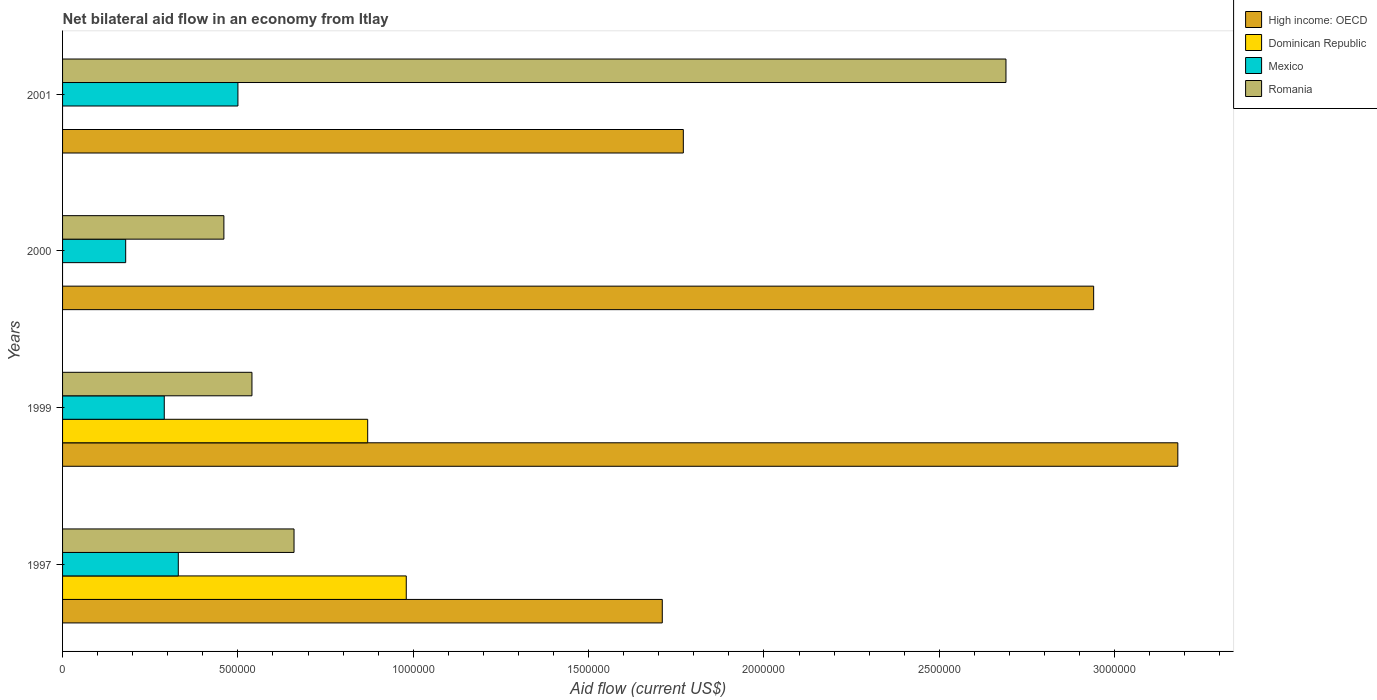How many different coloured bars are there?
Make the answer very short. 4. How many bars are there on the 2nd tick from the top?
Offer a very short reply. 3. How many bars are there on the 4th tick from the bottom?
Your response must be concise. 3. In how many cases, is the number of bars for a given year not equal to the number of legend labels?
Make the answer very short. 2. What is the net bilateral aid flow in High income: OECD in 1999?
Ensure brevity in your answer.  3.18e+06. Across all years, what is the maximum net bilateral aid flow in Dominican Republic?
Provide a succinct answer. 9.80e+05. Across all years, what is the minimum net bilateral aid flow in High income: OECD?
Give a very brief answer. 1.71e+06. What is the total net bilateral aid flow in Mexico in the graph?
Ensure brevity in your answer.  1.30e+06. What is the average net bilateral aid flow in Mexico per year?
Ensure brevity in your answer.  3.25e+05. In the year 2001, what is the difference between the net bilateral aid flow in High income: OECD and net bilateral aid flow in Romania?
Provide a succinct answer. -9.20e+05. In how many years, is the net bilateral aid flow in Mexico greater than 700000 US$?
Your answer should be compact. 0. What is the ratio of the net bilateral aid flow in Mexico in 1997 to that in 2001?
Your answer should be very brief. 0.66. Is the net bilateral aid flow in Romania in 1997 less than that in 2001?
Offer a terse response. Yes. What is the difference between the highest and the second highest net bilateral aid flow in Mexico?
Your response must be concise. 1.70e+05. What is the difference between the highest and the lowest net bilateral aid flow in Romania?
Provide a succinct answer. 2.23e+06. In how many years, is the net bilateral aid flow in High income: OECD greater than the average net bilateral aid flow in High income: OECD taken over all years?
Keep it short and to the point. 2. How many years are there in the graph?
Provide a succinct answer. 4. Are the values on the major ticks of X-axis written in scientific E-notation?
Ensure brevity in your answer.  No. Does the graph contain any zero values?
Offer a very short reply. Yes. Does the graph contain grids?
Provide a succinct answer. No. Where does the legend appear in the graph?
Keep it short and to the point. Top right. How are the legend labels stacked?
Offer a terse response. Vertical. What is the title of the graph?
Provide a succinct answer. Net bilateral aid flow in an economy from Itlay. What is the label or title of the X-axis?
Offer a terse response. Aid flow (current US$). What is the label or title of the Y-axis?
Your answer should be compact. Years. What is the Aid flow (current US$) in High income: OECD in 1997?
Provide a succinct answer. 1.71e+06. What is the Aid flow (current US$) of Dominican Republic in 1997?
Provide a short and direct response. 9.80e+05. What is the Aid flow (current US$) in Romania in 1997?
Offer a terse response. 6.60e+05. What is the Aid flow (current US$) of High income: OECD in 1999?
Your answer should be very brief. 3.18e+06. What is the Aid flow (current US$) in Dominican Republic in 1999?
Your answer should be compact. 8.70e+05. What is the Aid flow (current US$) of Romania in 1999?
Your answer should be very brief. 5.40e+05. What is the Aid flow (current US$) of High income: OECD in 2000?
Provide a succinct answer. 2.94e+06. What is the Aid flow (current US$) in Dominican Republic in 2000?
Keep it short and to the point. 0. What is the Aid flow (current US$) of Mexico in 2000?
Give a very brief answer. 1.80e+05. What is the Aid flow (current US$) of Romania in 2000?
Your answer should be very brief. 4.60e+05. What is the Aid flow (current US$) in High income: OECD in 2001?
Your answer should be compact. 1.77e+06. What is the Aid flow (current US$) in Mexico in 2001?
Provide a succinct answer. 5.00e+05. What is the Aid flow (current US$) of Romania in 2001?
Ensure brevity in your answer.  2.69e+06. Across all years, what is the maximum Aid flow (current US$) in High income: OECD?
Your answer should be compact. 3.18e+06. Across all years, what is the maximum Aid flow (current US$) of Dominican Republic?
Keep it short and to the point. 9.80e+05. Across all years, what is the maximum Aid flow (current US$) of Mexico?
Your response must be concise. 5.00e+05. Across all years, what is the maximum Aid flow (current US$) in Romania?
Provide a succinct answer. 2.69e+06. Across all years, what is the minimum Aid flow (current US$) of High income: OECD?
Your answer should be compact. 1.71e+06. Across all years, what is the minimum Aid flow (current US$) in Dominican Republic?
Keep it short and to the point. 0. Across all years, what is the minimum Aid flow (current US$) in Mexico?
Offer a very short reply. 1.80e+05. What is the total Aid flow (current US$) of High income: OECD in the graph?
Make the answer very short. 9.60e+06. What is the total Aid flow (current US$) in Dominican Republic in the graph?
Offer a very short reply. 1.85e+06. What is the total Aid flow (current US$) of Mexico in the graph?
Offer a terse response. 1.30e+06. What is the total Aid flow (current US$) of Romania in the graph?
Keep it short and to the point. 4.35e+06. What is the difference between the Aid flow (current US$) of High income: OECD in 1997 and that in 1999?
Ensure brevity in your answer.  -1.47e+06. What is the difference between the Aid flow (current US$) of Romania in 1997 and that in 1999?
Keep it short and to the point. 1.20e+05. What is the difference between the Aid flow (current US$) in High income: OECD in 1997 and that in 2000?
Make the answer very short. -1.23e+06. What is the difference between the Aid flow (current US$) in Mexico in 1997 and that in 2000?
Offer a terse response. 1.50e+05. What is the difference between the Aid flow (current US$) of Romania in 1997 and that in 2001?
Keep it short and to the point. -2.03e+06. What is the difference between the Aid flow (current US$) of High income: OECD in 1999 and that in 2000?
Provide a succinct answer. 2.40e+05. What is the difference between the Aid flow (current US$) of Mexico in 1999 and that in 2000?
Your answer should be compact. 1.10e+05. What is the difference between the Aid flow (current US$) in High income: OECD in 1999 and that in 2001?
Provide a short and direct response. 1.41e+06. What is the difference between the Aid flow (current US$) of Romania in 1999 and that in 2001?
Your answer should be very brief. -2.15e+06. What is the difference between the Aid flow (current US$) of High income: OECD in 2000 and that in 2001?
Give a very brief answer. 1.17e+06. What is the difference between the Aid flow (current US$) in Mexico in 2000 and that in 2001?
Keep it short and to the point. -3.20e+05. What is the difference between the Aid flow (current US$) of Romania in 2000 and that in 2001?
Your answer should be compact. -2.23e+06. What is the difference between the Aid flow (current US$) of High income: OECD in 1997 and the Aid flow (current US$) of Dominican Republic in 1999?
Provide a succinct answer. 8.40e+05. What is the difference between the Aid flow (current US$) of High income: OECD in 1997 and the Aid flow (current US$) of Mexico in 1999?
Provide a succinct answer. 1.42e+06. What is the difference between the Aid flow (current US$) in High income: OECD in 1997 and the Aid flow (current US$) in Romania in 1999?
Give a very brief answer. 1.17e+06. What is the difference between the Aid flow (current US$) in Dominican Republic in 1997 and the Aid flow (current US$) in Mexico in 1999?
Ensure brevity in your answer.  6.90e+05. What is the difference between the Aid flow (current US$) in High income: OECD in 1997 and the Aid flow (current US$) in Mexico in 2000?
Keep it short and to the point. 1.53e+06. What is the difference between the Aid flow (current US$) of High income: OECD in 1997 and the Aid flow (current US$) of Romania in 2000?
Your answer should be very brief. 1.25e+06. What is the difference between the Aid flow (current US$) of Dominican Republic in 1997 and the Aid flow (current US$) of Mexico in 2000?
Give a very brief answer. 8.00e+05. What is the difference between the Aid flow (current US$) of Dominican Republic in 1997 and the Aid flow (current US$) of Romania in 2000?
Keep it short and to the point. 5.20e+05. What is the difference between the Aid flow (current US$) in High income: OECD in 1997 and the Aid flow (current US$) in Mexico in 2001?
Keep it short and to the point. 1.21e+06. What is the difference between the Aid flow (current US$) of High income: OECD in 1997 and the Aid flow (current US$) of Romania in 2001?
Your answer should be compact. -9.80e+05. What is the difference between the Aid flow (current US$) in Dominican Republic in 1997 and the Aid flow (current US$) in Romania in 2001?
Offer a very short reply. -1.71e+06. What is the difference between the Aid flow (current US$) of Mexico in 1997 and the Aid flow (current US$) of Romania in 2001?
Your answer should be very brief. -2.36e+06. What is the difference between the Aid flow (current US$) in High income: OECD in 1999 and the Aid flow (current US$) in Mexico in 2000?
Offer a terse response. 3.00e+06. What is the difference between the Aid flow (current US$) in High income: OECD in 1999 and the Aid flow (current US$) in Romania in 2000?
Provide a short and direct response. 2.72e+06. What is the difference between the Aid flow (current US$) of Dominican Republic in 1999 and the Aid flow (current US$) of Mexico in 2000?
Your answer should be compact. 6.90e+05. What is the difference between the Aid flow (current US$) in Mexico in 1999 and the Aid flow (current US$) in Romania in 2000?
Your answer should be compact. -1.70e+05. What is the difference between the Aid flow (current US$) of High income: OECD in 1999 and the Aid flow (current US$) of Mexico in 2001?
Your answer should be compact. 2.68e+06. What is the difference between the Aid flow (current US$) of Dominican Republic in 1999 and the Aid flow (current US$) of Romania in 2001?
Keep it short and to the point. -1.82e+06. What is the difference between the Aid flow (current US$) in Mexico in 1999 and the Aid flow (current US$) in Romania in 2001?
Provide a short and direct response. -2.40e+06. What is the difference between the Aid flow (current US$) of High income: OECD in 2000 and the Aid flow (current US$) of Mexico in 2001?
Your response must be concise. 2.44e+06. What is the difference between the Aid flow (current US$) in High income: OECD in 2000 and the Aid flow (current US$) in Romania in 2001?
Offer a terse response. 2.50e+05. What is the difference between the Aid flow (current US$) in Mexico in 2000 and the Aid flow (current US$) in Romania in 2001?
Your response must be concise. -2.51e+06. What is the average Aid flow (current US$) in High income: OECD per year?
Your answer should be very brief. 2.40e+06. What is the average Aid flow (current US$) in Dominican Republic per year?
Ensure brevity in your answer.  4.62e+05. What is the average Aid flow (current US$) in Mexico per year?
Provide a succinct answer. 3.25e+05. What is the average Aid flow (current US$) in Romania per year?
Your response must be concise. 1.09e+06. In the year 1997, what is the difference between the Aid flow (current US$) in High income: OECD and Aid flow (current US$) in Dominican Republic?
Give a very brief answer. 7.30e+05. In the year 1997, what is the difference between the Aid flow (current US$) of High income: OECD and Aid flow (current US$) of Mexico?
Offer a very short reply. 1.38e+06. In the year 1997, what is the difference between the Aid flow (current US$) in High income: OECD and Aid flow (current US$) in Romania?
Your response must be concise. 1.05e+06. In the year 1997, what is the difference between the Aid flow (current US$) in Dominican Republic and Aid flow (current US$) in Mexico?
Offer a terse response. 6.50e+05. In the year 1997, what is the difference between the Aid flow (current US$) in Dominican Republic and Aid flow (current US$) in Romania?
Your answer should be very brief. 3.20e+05. In the year 1997, what is the difference between the Aid flow (current US$) in Mexico and Aid flow (current US$) in Romania?
Your answer should be very brief. -3.30e+05. In the year 1999, what is the difference between the Aid flow (current US$) of High income: OECD and Aid flow (current US$) of Dominican Republic?
Make the answer very short. 2.31e+06. In the year 1999, what is the difference between the Aid flow (current US$) in High income: OECD and Aid flow (current US$) in Mexico?
Offer a very short reply. 2.89e+06. In the year 1999, what is the difference between the Aid flow (current US$) in High income: OECD and Aid flow (current US$) in Romania?
Provide a short and direct response. 2.64e+06. In the year 1999, what is the difference between the Aid flow (current US$) of Dominican Republic and Aid flow (current US$) of Mexico?
Ensure brevity in your answer.  5.80e+05. In the year 1999, what is the difference between the Aid flow (current US$) in Dominican Republic and Aid flow (current US$) in Romania?
Offer a very short reply. 3.30e+05. In the year 1999, what is the difference between the Aid flow (current US$) in Mexico and Aid flow (current US$) in Romania?
Provide a short and direct response. -2.50e+05. In the year 2000, what is the difference between the Aid flow (current US$) in High income: OECD and Aid flow (current US$) in Mexico?
Keep it short and to the point. 2.76e+06. In the year 2000, what is the difference between the Aid flow (current US$) of High income: OECD and Aid flow (current US$) of Romania?
Your answer should be very brief. 2.48e+06. In the year 2000, what is the difference between the Aid flow (current US$) in Mexico and Aid flow (current US$) in Romania?
Your answer should be very brief. -2.80e+05. In the year 2001, what is the difference between the Aid flow (current US$) in High income: OECD and Aid flow (current US$) in Mexico?
Make the answer very short. 1.27e+06. In the year 2001, what is the difference between the Aid flow (current US$) in High income: OECD and Aid flow (current US$) in Romania?
Provide a succinct answer. -9.20e+05. In the year 2001, what is the difference between the Aid flow (current US$) in Mexico and Aid flow (current US$) in Romania?
Make the answer very short. -2.19e+06. What is the ratio of the Aid flow (current US$) of High income: OECD in 1997 to that in 1999?
Keep it short and to the point. 0.54. What is the ratio of the Aid flow (current US$) in Dominican Republic in 1997 to that in 1999?
Provide a succinct answer. 1.13. What is the ratio of the Aid flow (current US$) of Mexico in 1997 to that in 1999?
Your response must be concise. 1.14. What is the ratio of the Aid flow (current US$) in Romania in 1997 to that in 1999?
Keep it short and to the point. 1.22. What is the ratio of the Aid flow (current US$) of High income: OECD in 1997 to that in 2000?
Your response must be concise. 0.58. What is the ratio of the Aid flow (current US$) in Mexico in 1997 to that in 2000?
Give a very brief answer. 1.83. What is the ratio of the Aid flow (current US$) of Romania in 1997 to that in 2000?
Provide a succinct answer. 1.43. What is the ratio of the Aid flow (current US$) of High income: OECD in 1997 to that in 2001?
Offer a very short reply. 0.97. What is the ratio of the Aid flow (current US$) of Mexico in 1997 to that in 2001?
Give a very brief answer. 0.66. What is the ratio of the Aid flow (current US$) in Romania in 1997 to that in 2001?
Provide a short and direct response. 0.25. What is the ratio of the Aid flow (current US$) in High income: OECD in 1999 to that in 2000?
Ensure brevity in your answer.  1.08. What is the ratio of the Aid flow (current US$) of Mexico in 1999 to that in 2000?
Offer a very short reply. 1.61. What is the ratio of the Aid flow (current US$) of Romania in 1999 to that in 2000?
Make the answer very short. 1.17. What is the ratio of the Aid flow (current US$) of High income: OECD in 1999 to that in 2001?
Provide a succinct answer. 1.8. What is the ratio of the Aid flow (current US$) of Mexico in 1999 to that in 2001?
Provide a succinct answer. 0.58. What is the ratio of the Aid flow (current US$) of Romania in 1999 to that in 2001?
Make the answer very short. 0.2. What is the ratio of the Aid flow (current US$) in High income: OECD in 2000 to that in 2001?
Your answer should be compact. 1.66. What is the ratio of the Aid flow (current US$) of Mexico in 2000 to that in 2001?
Your answer should be compact. 0.36. What is the ratio of the Aid flow (current US$) of Romania in 2000 to that in 2001?
Keep it short and to the point. 0.17. What is the difference between the highest and the second highest Aid flow (current US$) in Mexico?
Offer a terse response. 1.70e+05. What is the difference between the highest and the second highest Aid flow (current US$) in Romania?
Your answer should be compact. 2.03e+06. What is the difference between the highest and the lowest Aid flow (current US$) in High income: OECD?
Ensure brevity in your answer.  1.47e+06. What is the difference between the highest and the lowest Aid flow (current US$) in Dominican Republic?
Make the answer very short. 9.80e+05. What is the difference between the highest and the lowest Aid flow (current US$) of Romania?
Ensure brevity in your answer.  2.23e+06. 